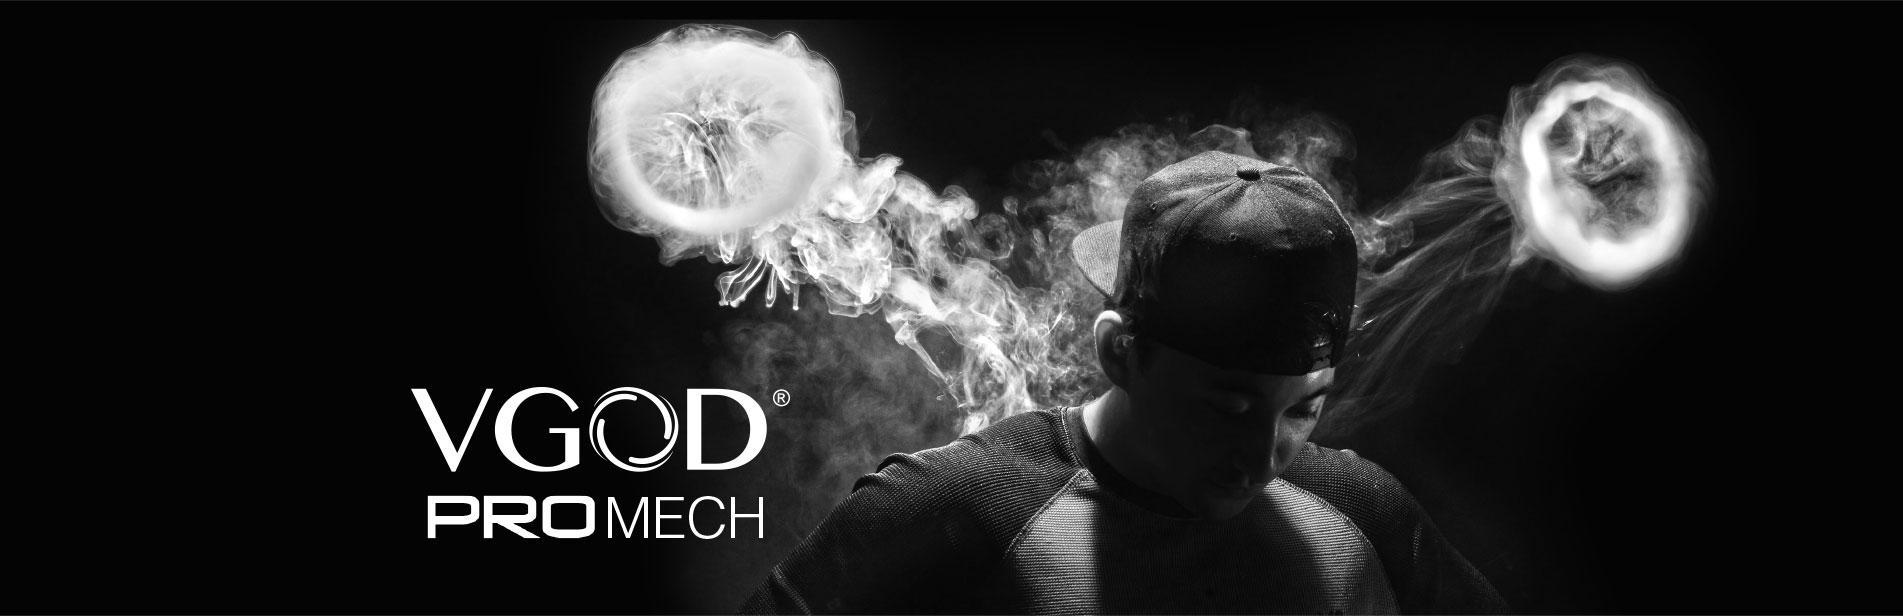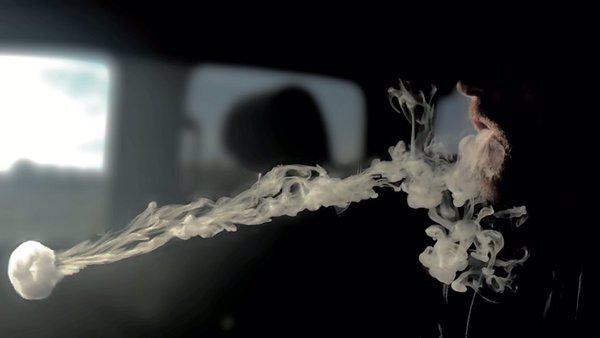The first image is the image on the left, the second image is the image on the right. Evaluate the accuracy of this statement regarding the images: "There are exactly two smoke rings.". Is it true? Answer yes or no. No. The first image is the image on the left, the second image is the image on the right. Evaluate the accuracy of this statement regarding the images: "The left and right image contains the same number of jelly fish looking smoke rings.". Is it true? Answer yes or no. No. 